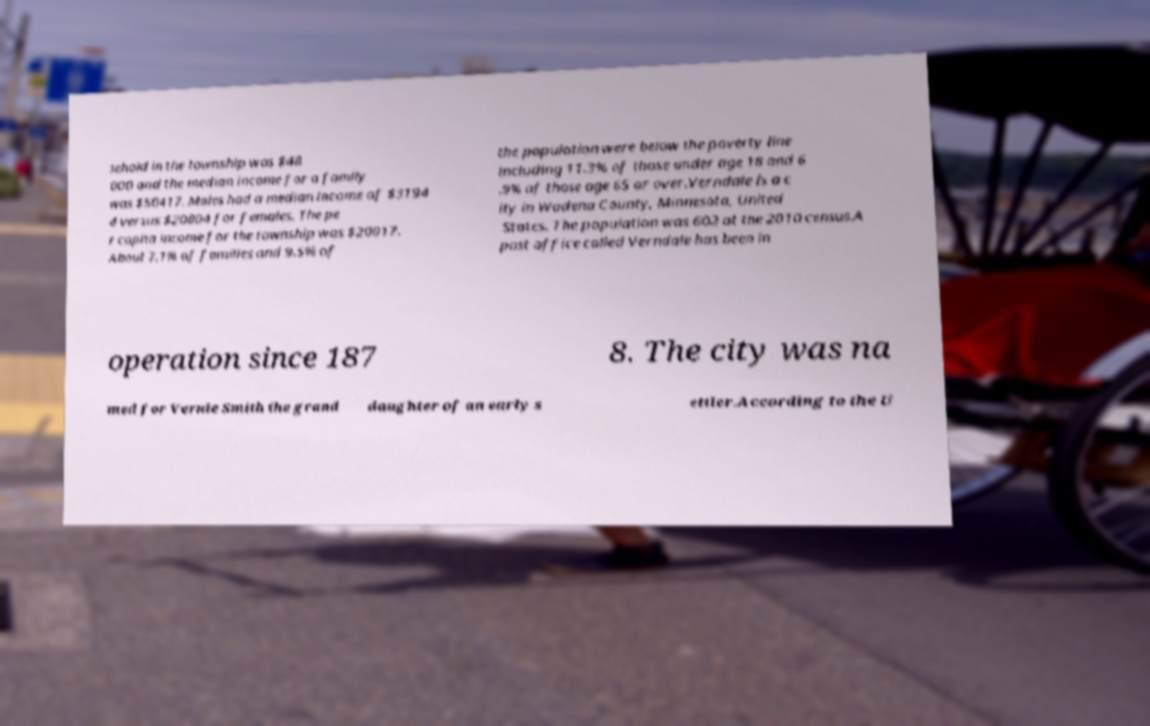Please read and relay the text visible in this image. What does it say? sehold in the township was $48 000 and the median income for a family was $50417. Males had a median income of $3194 4 versus $20804 for females. The pe r capita income for the township was $20017. About 7.1% of families and 9.5% of the population were below the poverty line including 11.3% of those under age 18 and 6 .9% of those age 65 or over.Verndale is a c ity in Wadena County, Minnesota, United States. The population was 602 at the 2010 census.A post office called Verndale has been in operation since 187 8. The city was na med for Vernie Smith the grand daughter of an early s ettler.According to the U 